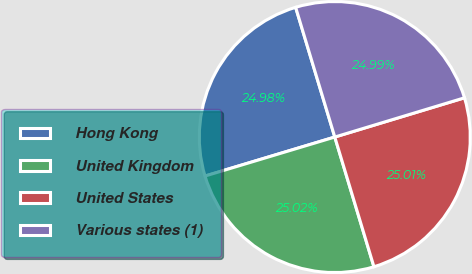Convert chart to OTSL. <chart><loc_0><loc_0><loc_500><loc_500><pie_chart><fcel>Hong Kong<fcel>United Kingdom<fcel>United States<fcel>Various states (1)<nl><fcel>24.98%<fcel>25.02%<fcel>25.01%<fcel>24.99%<nl></chart> 